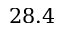Convert formula to latex. <formula><loc_0><loc_0><loc_500><loc_500>2 8 . 4</formula> 